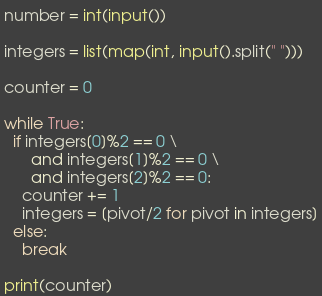Convert code to text. <code><loc_0><loc_0><loc_500><loc_500><_Python_>number = int(input())

integers = list(map(int, input().split(" ")))

counter = 0

while True:
  if integers[0]%2 == 0 \
	  and integers[1]%2 == 0 \
	  and integers[2]%2 == 0:
    counter += 1
    integers = [pivot/2 for pivot in integers]
  else:
    break

print(counter)</code> 